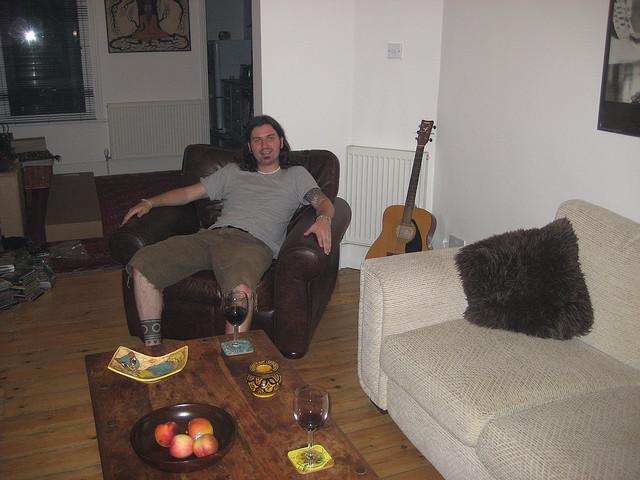How many pillows are on the couch?
Be succinct. 1. What is the table made of?
Be succinct. Wood. Is  the man wearing a tie?
Be succinct. No. Why is the man sitting in the lounge hair?
Keep it brief. Relaxing. What instrument is pictured?
Keep it brief. Guitar. 